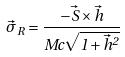Convert formula to latex. <formula><loc_0><loc_0><loc_500><loc_500>\vec { \sigma } _ { R } = \frac { - \vec { S } \times \vec { h } } { M c \sqrt { 1 + \vec { h } ^ { 2 } } }</formula> 